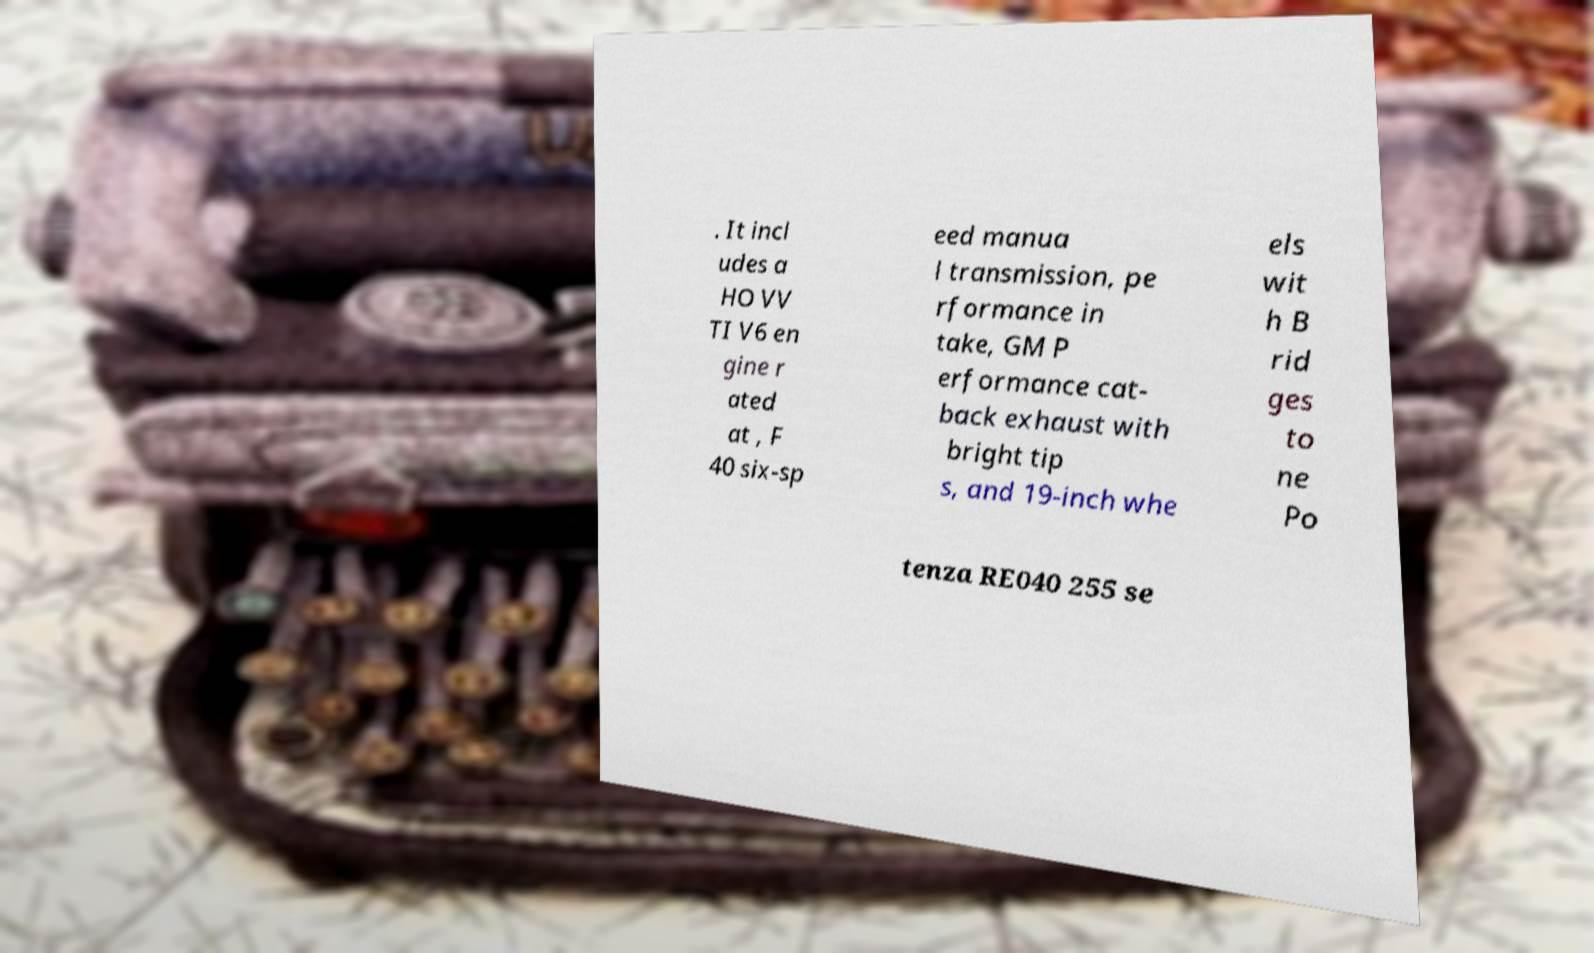Please identify and transcribe the text found in this image. . It incl udes a HO VV TI V6 en gine r ated at , F 40 six-sp eed manua l transmission, pe rformance in take, GM P erformance cat- back exhaust with bright tip s, and 19-inch whe els wit h B rid ges to ne Po tenza RE040 255 se 